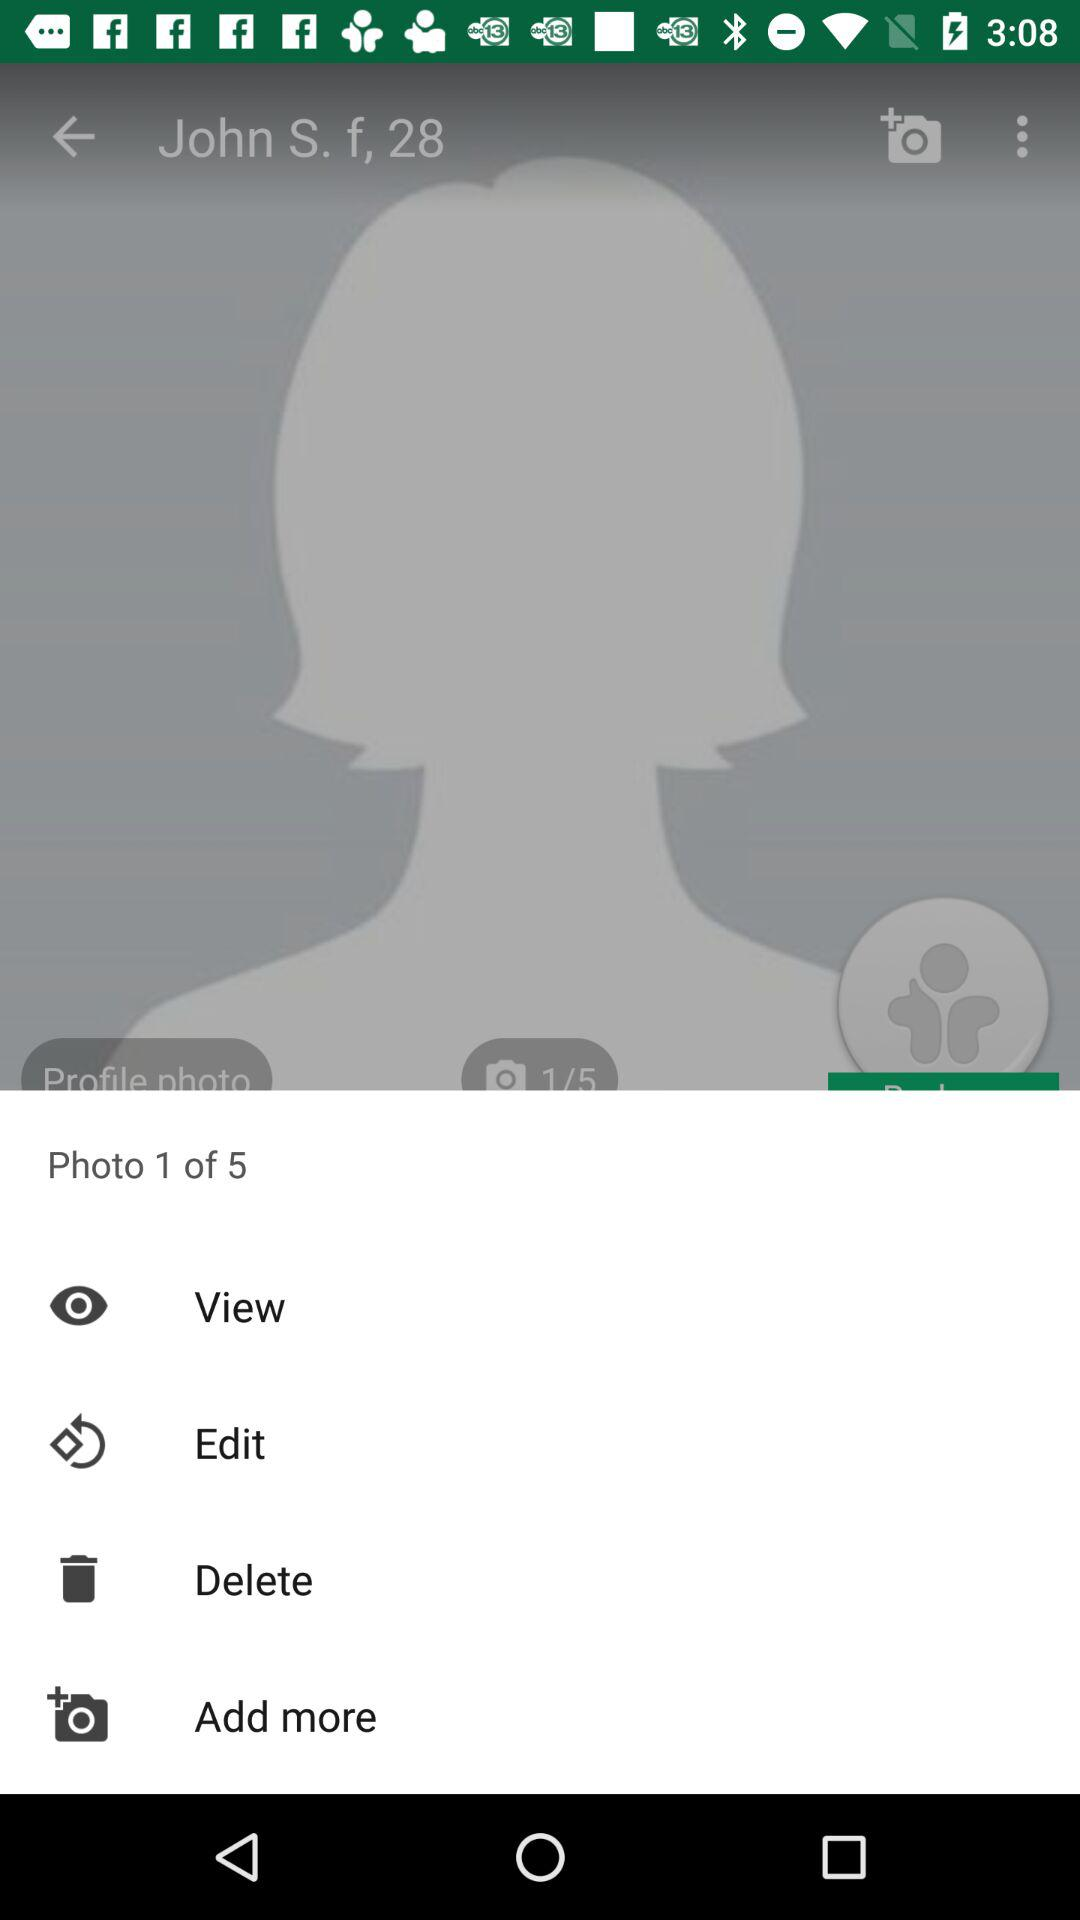What is the age of the user? The age is 28. 